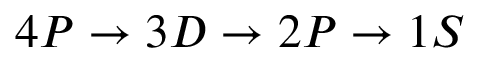Convert formula to latex. <formula><loc_0><loc_0><loc_500><loc_500>4 P \rightarrow 3 D \rightarrow 2 P \rightarrow 1 S</formula> 